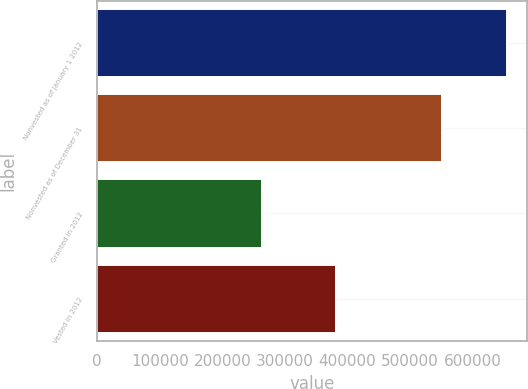<chart> <loc_0><loc_0><loc_500><loc_500><bar_chart><fcel>Nonvested as of January 1 2012<fcel>Nonvested as of December 31<fcel>Granted in 2012<fcel>Vested in 2012<nl><fcel>654696<fcel>551678<fcel>263771<fcel>380970<nl></chart> 